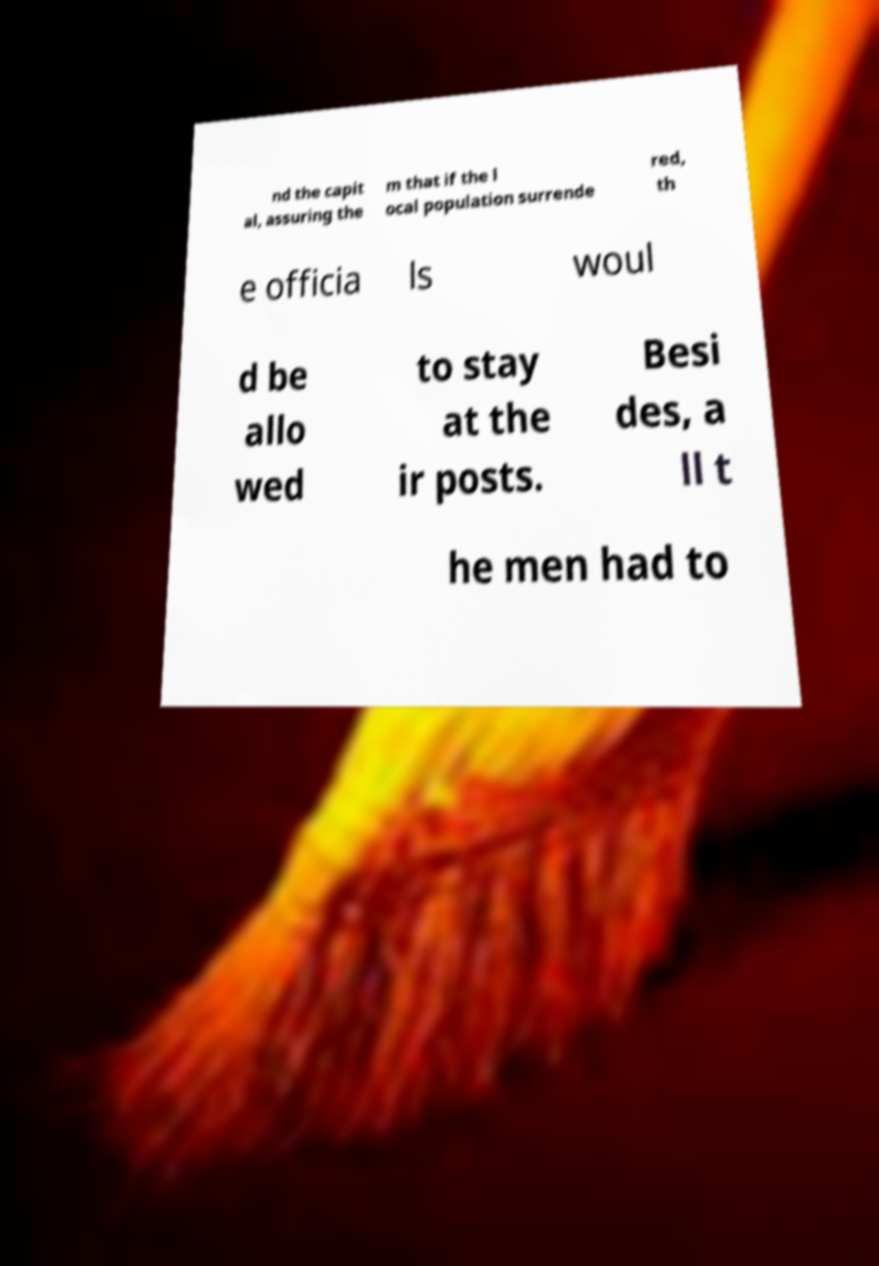Could you extract and type out the text from this image? nd the capit al, assuring the m that if the l ocal population surrende red, th e officia ls woul d be allo wed to stay at the ir posts. Besi des, a ll t he men had to 